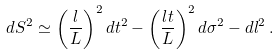<formula> <loc_0><loc_0><loc_500><loc_500>d S ^ { 2 } \simeq \left ( \frac { l } { L } \right ) ^ { 2 } d t ^ { 2 } - \left ( \frac { l t } { L } \right ) ^ { 2 } d \sigma ^ { 2 } - d l ^ { 2 } \, .</formula> 